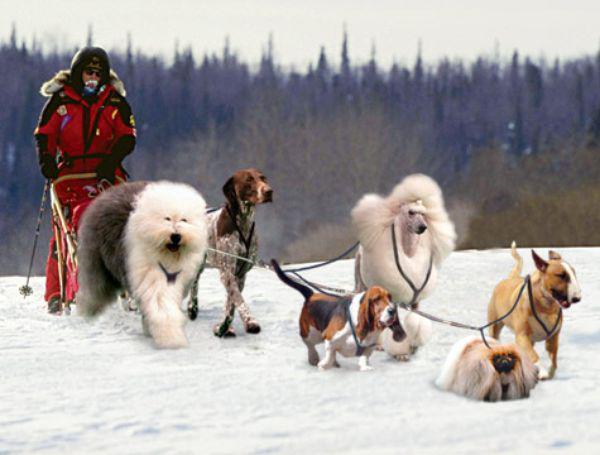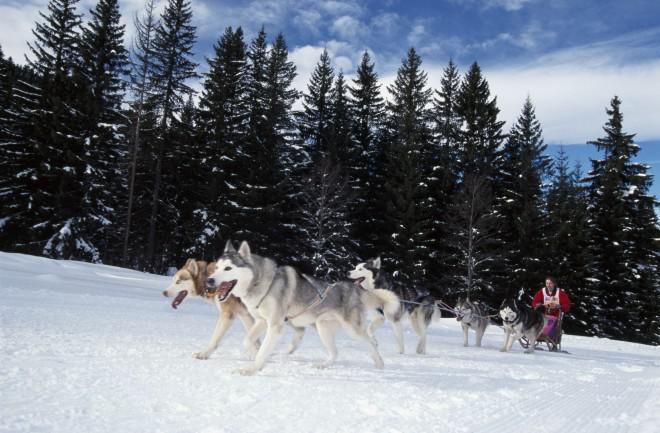The first image is the image on the left, the second image is the image on the right. Given the left and right images, does the statement "The dogs in both pictures are pulling the sled towards the right." hold true? Answer yes or no. No. The first image is the image on the left, the second image is the image on the right. For the images displayed, is the sentence "The dog sled teams in the left and right images move rightward at an angle over the snow and contain traditional husky-type sled dogs." factually correct? Answer yes or no. No. 